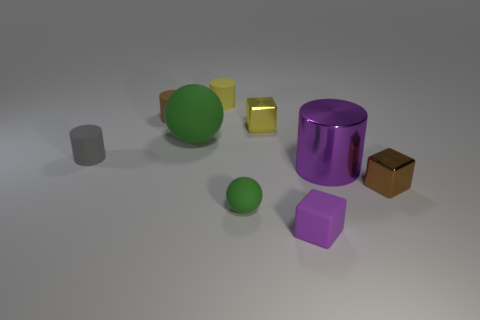What number of small rubber cylinders are right of the tiny brown matte cylinder and on the left side of the small brown rubber thing?
Keep it short and to the point. 0. How many objects are either matte things behind the brown metal cube or tiny objects that are on the right side of the big metal thing?
Keep it short and to the point. 5. How many other objects are the same shape as the tiny gray matte thing?
Make the answer very short. 3. There is a small cylinder that is in front of the big ball; is it the same color as the small rubber sphere?
Offer a terse response. No. How many other things are there of the same size as the yellow rubber object?
Your response must be concise. 6. Are the small brown block and the brown cylinder made of the same material?
Keep it short and to the point. No. There is a metallic cube that is behind the small object that is on the right side of the large purple thing; what is its color?
Your answer should be very brief. Yellow. What size is the gray object that is the same shape as the big purple thing?
Keep it short and to the point. Small. Does the large matte object have the same color as the matte cube?
Your answer should be compact. No. How many brown things are behind the metallic cube that is right of the tiny matte object that is in front of the tiny green thing?
Provide a succinct answer. 1. 